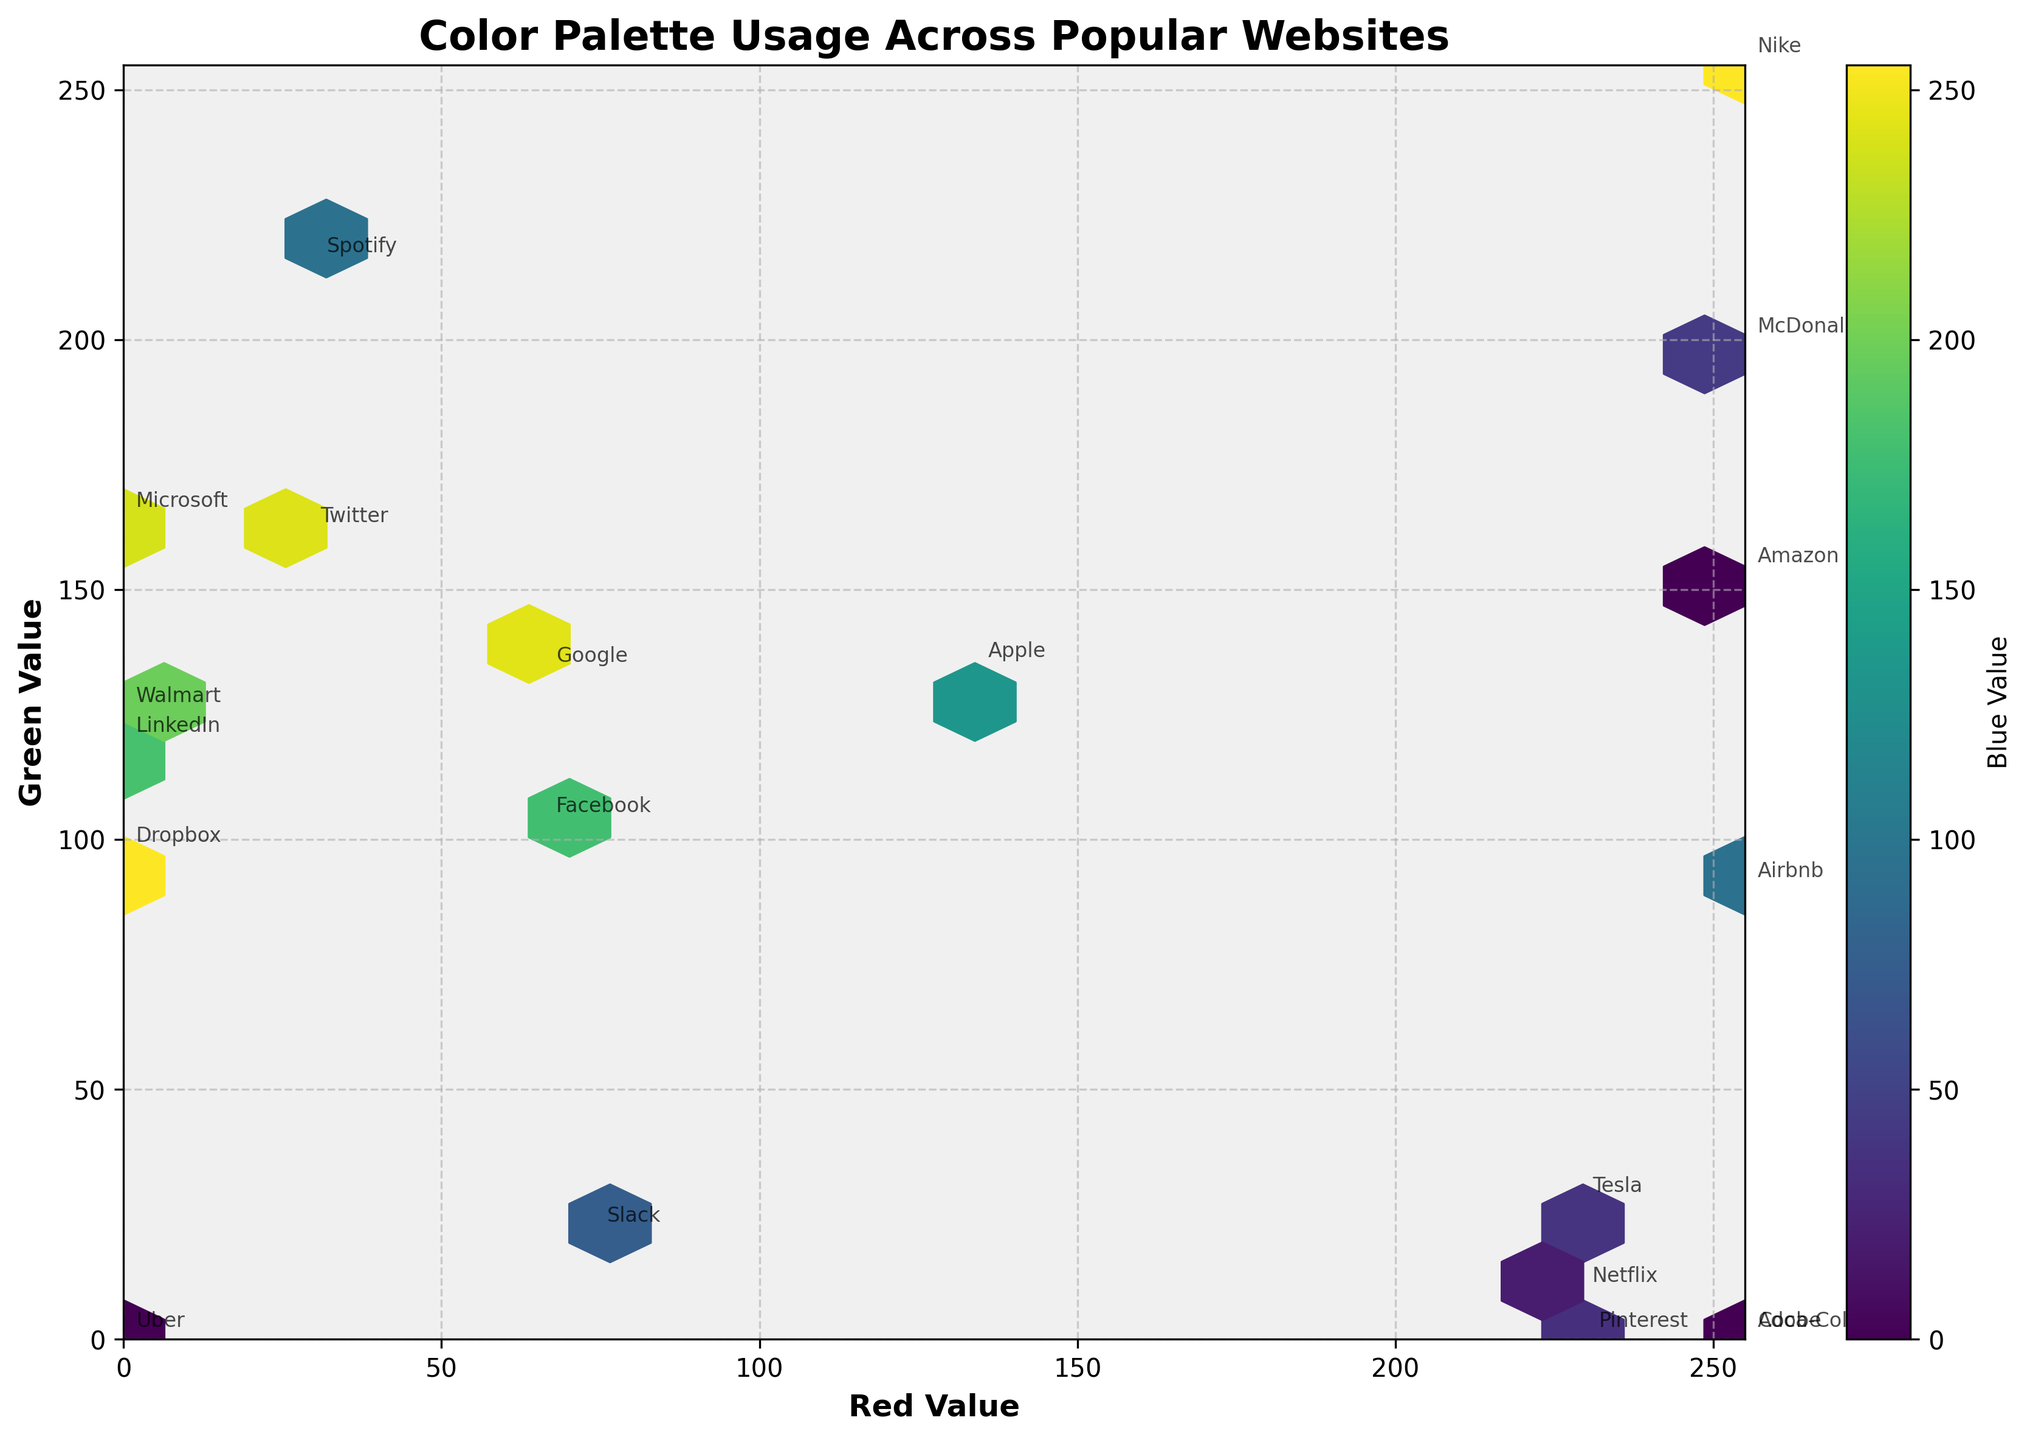Which website has the highest green value? Look for the website name at the data point where the 'Green Value' (y-axis) is the highest. This website is Spotify.
Answer: Spotify Which industries use colors with higher 'Red Values'? Check the concentration of data points towards the right side of the plot (higher 'Red Values' on the x-axis) and note the corresponding industries. 'Entertainment', 'Travel', 'Food', and 'Automotive' industries show higher 'Red Values'.
Answer: Entertainment, Travel, Food, Automotive What is the most common range of blue values in the hexbin plot? The color bar indicates the 'Blue Value' distribution across the bins. Observe the predominant color within the hexbin plot and match it to the range in the color bar scale. The lighter (yellow) color is most common, suggesting a blue value range between 50 and 150.
Answer: 50-150 Which hexagons have the highest concentration of data points? The color intensity of hexagons indicates the concentration. The hexagons with a denser cluster (most distinct color within the colormap) are located around the mid to high values of the red and green axes, indicating high concentration around the middle range.
Answer: Mid to high values of red and green How do the 'Red Value' and 'Green Value' relate to each other across different industries? Examine the correlation indicated by the placement of data points. If data points are more aligned along a diagonal from bottom-left to top-right, there is a positive correlation, meaning as Red increases, Green typically increases too.
Answer: Positive correlation Which website has the highest overall color intensity based on the three color channels? The overall color intensity can be implied by the data point's placement and concentration area on the hexbin plot. Amazon has high red and moderate green, combined with its blue value, it portrays high intensity.
Answer: Amazon Are there more websites with higher green values than red values? Compare the number of data points positioned higher on the y-axis than on the x-axis. There are fewer websites with higher green values than red values, indicating a majority having higher red values.
Answer: No Among the plotted websites, which has the lowest green value? Identify the data point with the lowest position along the y-axis and note its corresponding website. Adobe has the lowest green value.
Answer: Adobe Are there any industries that tightly cluster within a specific color range? Look for groups of points from the same industry that are close together within a certain area of the plot. Social Media websites, for instance, cluster around moderate red and green values.
Answer: Social Media How are the color palettes of technology versus social media websites different? By comparing data points in terms of their RGB values, generally, technology websites show a wider distribution across the red, green, and blue values, while social media websites trend towards moderate red and green and varying blue values.
Answer: Technology: wide distribution; Social Media: moderate red/green, varying blue 